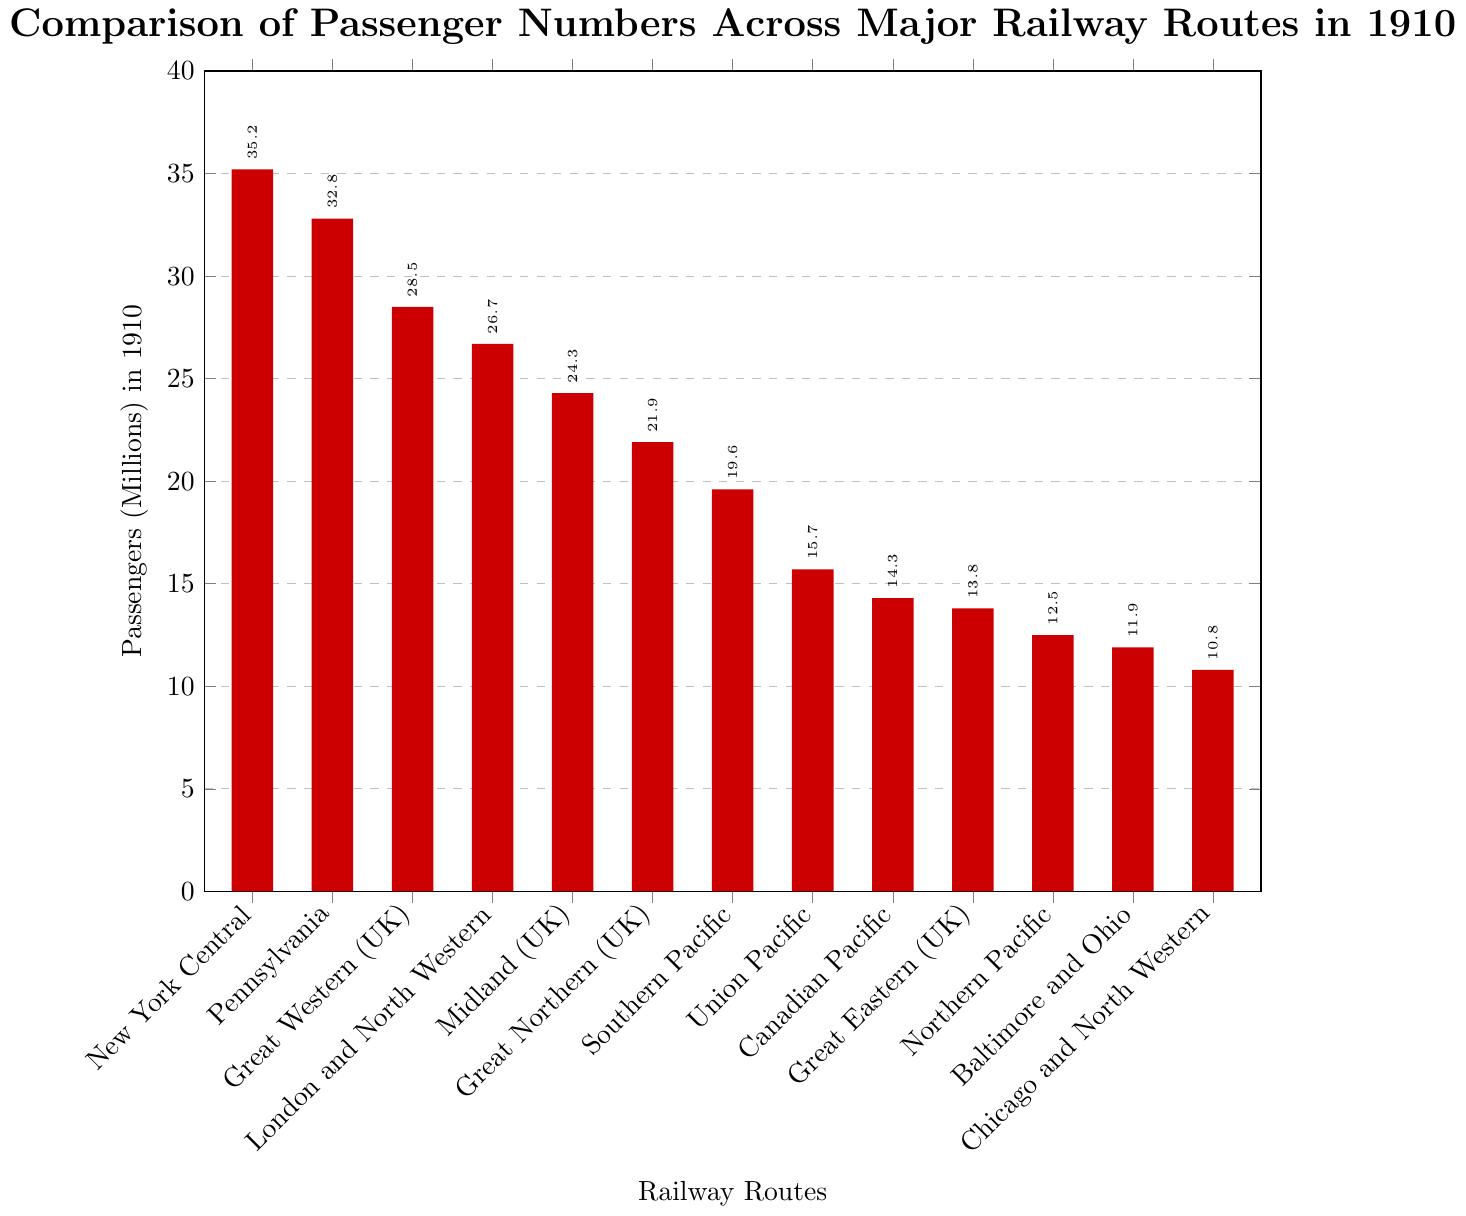Which railway route had the highest number of passengers in 1910? The highest bar on the chart represents the railway route with the most passengers. In this case, it's the New York Central Railroad.
Answer: New York Central Railroad What is the total number of passengers transported by the three busiest railway routes? To find the total, identify the three highest bars and sum their values. They are New York Central Railroad (35.2), Pennsylvania Railroad (32.8), and Great Western Railway (28.5). Sum these values: 35.2 + 32.8 + 28.5 = 96.5 million passengers.
Answer: 96.5 million How many more passengers did the New York Central Railroad have compared to the Chicago and North Western Railway? Subtract the number of passengers for Chicago and North Western Railway from New York Central Railroad. 35.2 million - 10.8 million = 24.4 million.
Answer: 24.4 million Which railway route had the lowest number of passengers in 1910? The lowest bar on the chart represents the railway route with the fewest passengers. In this case, it's the Chicago and North Western Railway.
Answer: Chicago and North Western Railway Between the Northern and Southern Pacific Railways, which had more passengers and by how much? Identify the bars for Northern Pacific and Southern Pacific Railways. Southern Pacific had 19.6 million passengers, while Northern Pacific had 12.5 million. The difference is 19.6 million - 12.5 million = 7.1 million.
Answer: Southern Pacific, 7.1 million What is the average number of passengers of all the routes combined? First, sum the number of passengers for all routes: 35.2 + 32.8 + 28.5 + 26.7 + 24.3 + 21.9 + 19.6 + 15.7 + 14.3 + 13.8 + 12.5 + 11.9 + 10.8 = 268.0 million. Then, divide this by the number of routes, which is 13. 268.0 / 13 ≈ 20.6 million.
Answer: 20.6 million Which UK railway route had the highest number of passengers? Among the UK routes (Great Western, London and North Western, Midland, Great Northern, and Great Eastern), the highest bar corresponds to the Great Western Railway (28.5 million).
Answer: Great Western Railway Is the number of passengers for each of the top five routes higher than the total number for the bottom five routes? Sum the top five routes: 35.2 (New York Central) + 32.8 (Pennsylvania) + 28.5 (Great Western) + 26.7 (London and North Western) + 24.3 (Midland) = 147.5 million. Sum the bottom five routes: 14.3 (Canadian Pacific) + 13.8 (Great Eastern) + 12.5 (Northern Pacific) + 11.9 (Baltimore and Ohio) + 10.8 (Chicago and North Western) = 63.3 million. Since 147.5 million > 63.3 million, the answer is yes.
Answer: Yes 